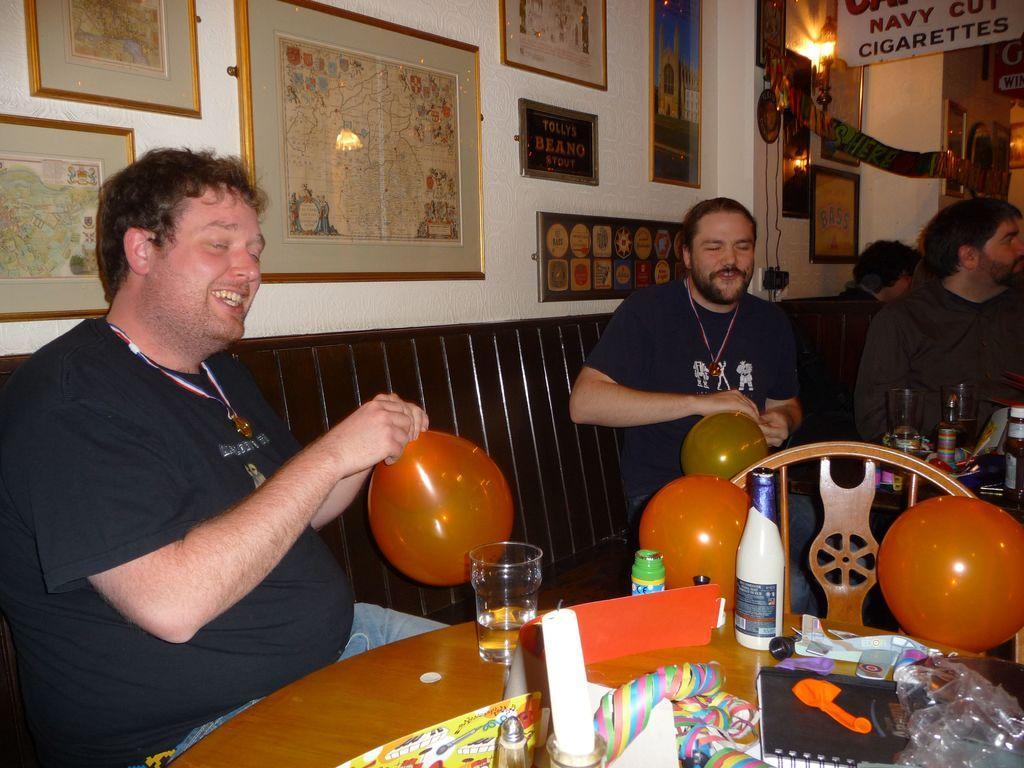In one or two sentences, can you explain what this image depicts? This is an inside view of a room. Here I can see few people are sitting on the bench. Two men are holding balloons in their hands and smiling. In front of these people there is a table on which I can see few bottles, balloons, glass, book, toys and some other objects. At the back of these people there is a wall to which many photo frames are attached. In the top right, I can see a white color board on which I can see some text. 